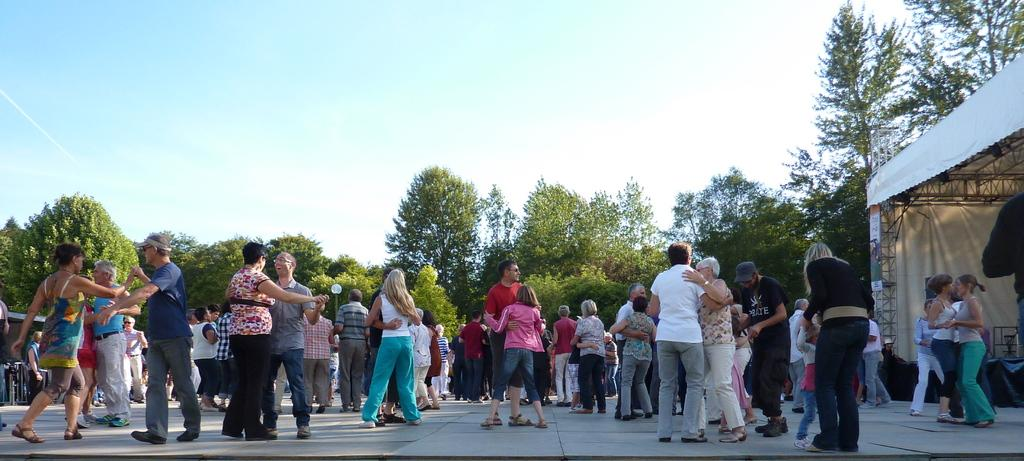What are the people in the image doing? The persons standing on the floor in the image are likely standing or interacting with each other. What can be seen in the background of the image? In the background of the image, there are iron grills, a tent, trees, and the sky. Can you describe the setting of the image? The image appears to be set outdoors, with a tent and trees in the background, and the sky visible above. What type of organization is responsible for the cup seen in the image? There is no cup present in the image, so it is not possible to determine which organization might be responsible for it. 